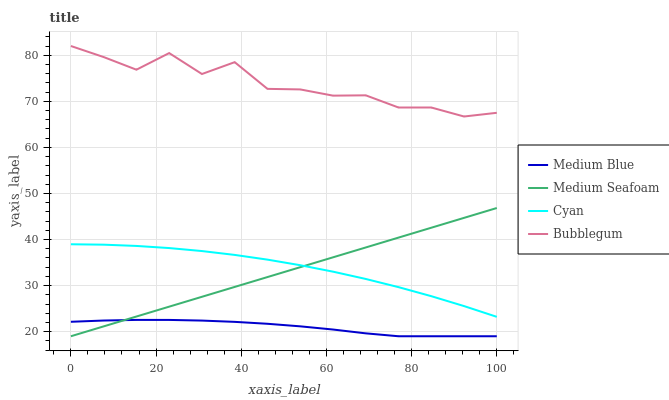Does Medium Blue have the minimum area under the curve?
Answer yes or no. Yes. Does Bubblegum have the maximum area under the curve?
Answer yes or no. Yes. Does Medium Seafoam have the minimum area under the curve?
Answer yes or no. No. Does Medium Seafoam have the maximum area under the curve?
Answer yes or no. No. Is Medium Seafoam the smoothest?
Answer yes or no. Yes. Is Bubblegum the roughest?
Answer yes or no. Yes. Is Medium Blue the smoothest?
Answer yes or no. No. Is Medium Blue the roughest?
Answer yes or no. No. Does Medium Blue have the lowest value?
Answer yes or no. Yes. Does Bubblegum have the lowest value?
Answer yes or no. No. Does Bubblegum have the highest value?
Answer yes or no. Yes. Does Medium Seafoam have the highest value?
Answer yes or no. No. Is Medium Blue less than Cyan?
Answer yes or no. Yes. Is Bubblegum greater than Medium Seafoam?
Answer yes or no. Yes. Does Cyan intersect Medium Seafoam?
Answer yes or no. Yes. Is Cyan less than Medium Seafoam?
Answer yes or no. No. Is Cyan greater than Medium Seafoam?
Answer yes or no. No. Does Medium Blue intersect Cyan?
Answer yes or no. No. 